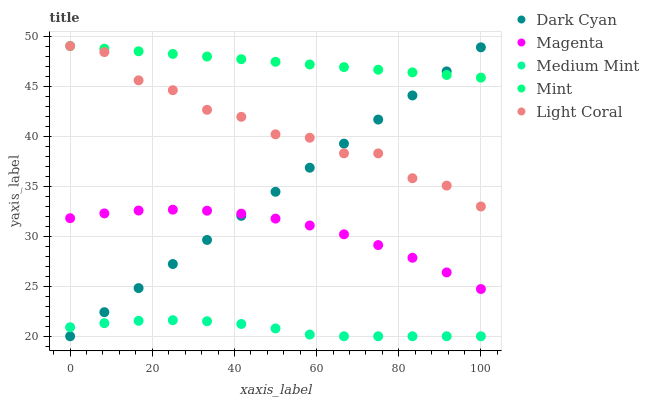Does Medium Mint have the minimum area under the curve?
Answer yes or no. Yes. Does Mint have the maximum area under the curve?
Answer yes or no. Yes. Does Magenta have the minimum area under the curve?
Answer yes or no. No. Does Magenta have the maximum area under the curve?
Answer yes or no. No. Is Dark Cyan the smoothest?
Answer yes or no. Yes. Is Light Coral the roughest?
Answer yes or no. Yes. Is Medium Mint the smoothest?
Answer yes or no. No. Is Medium Mint the roughest?
Answer yes or no. No. Does Dark Cyan have the lowest value?
Answer yes or no. Yes. Does Magenta have the lowest value?
Answer yes or no. No. Does Light Coral have the highest value?
Answer yes or no. Yes. Does Magenta have the highest value?
Answer yes or no. No. Is Medium Mint less than Magenta?
Answer yes or no. Yes. Is Magenta greater than Medium Mint?
Answer yes or no. Yes. Does Medium Mint intersect Dark Cyan?
Answer yes or no. Yes. Is Medium Mint less than Dark Cyan?
Answer yes or no. No. Is Medium Mint greater than Dark Cyan?
Answer yes or no. No. Does Medium Mint intersect Magenta?
Answer yes or no. No. 